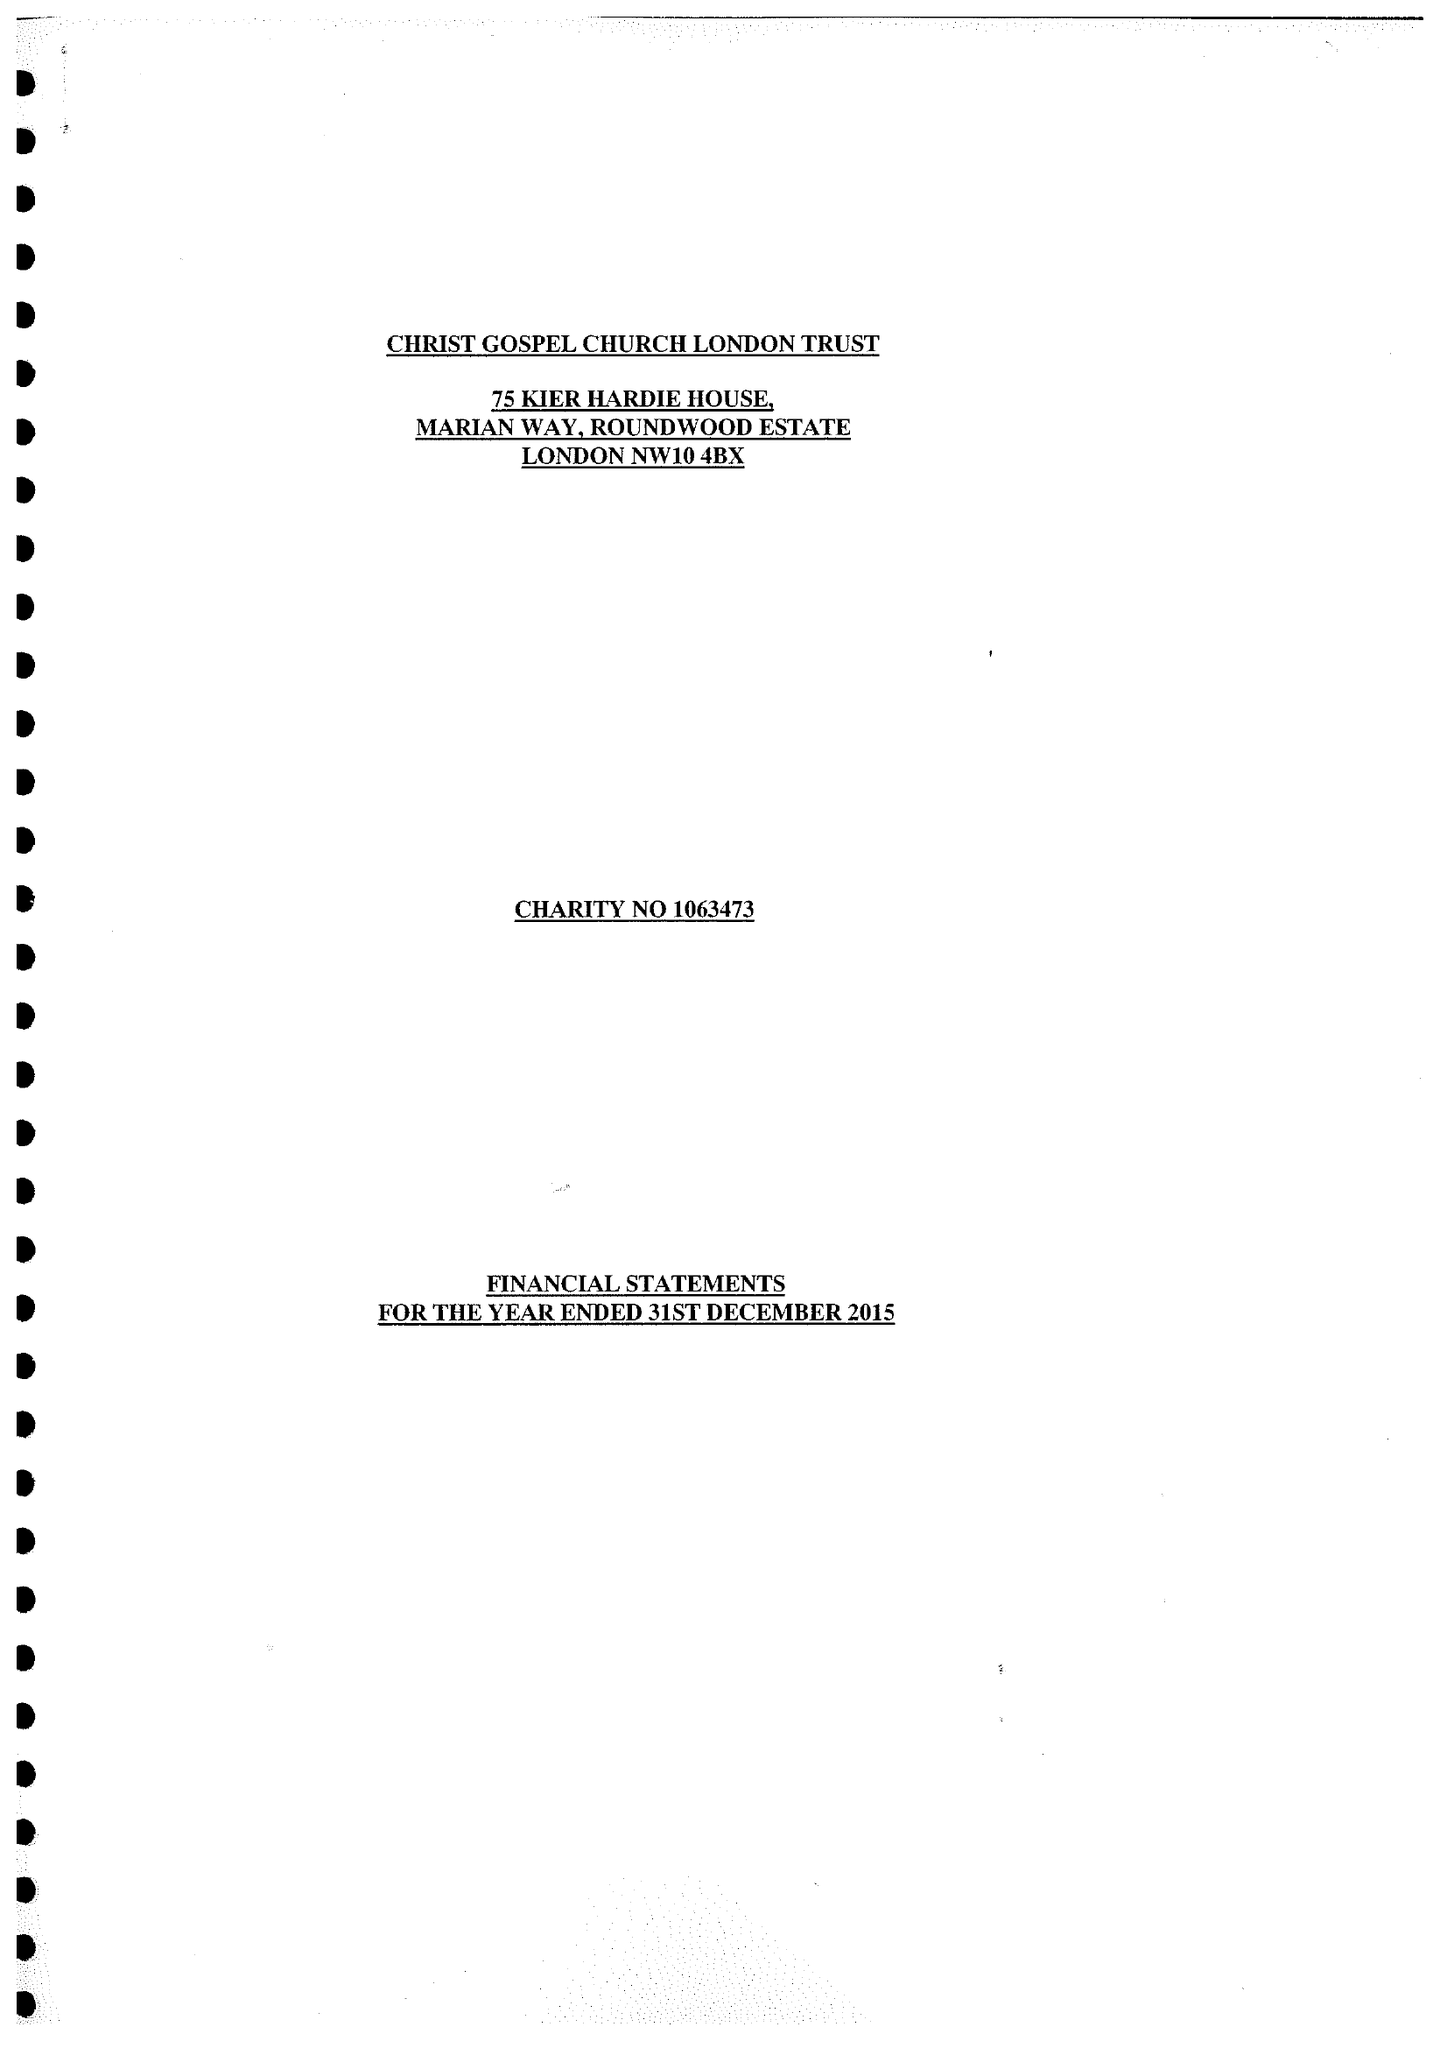What is the value for the address__street_line?
Answer the question using a single word or phrase. MARIAN WAY 